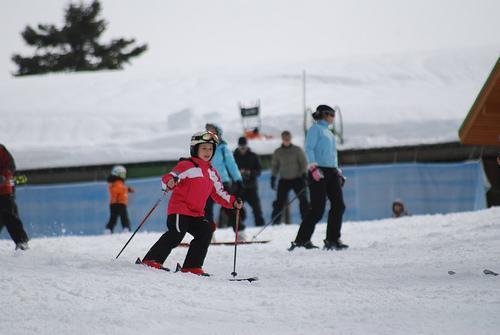How many people can you see?
Give a very brief answer. 3. How many chairs with cushions are there?
Give a very brief answer. 0. 